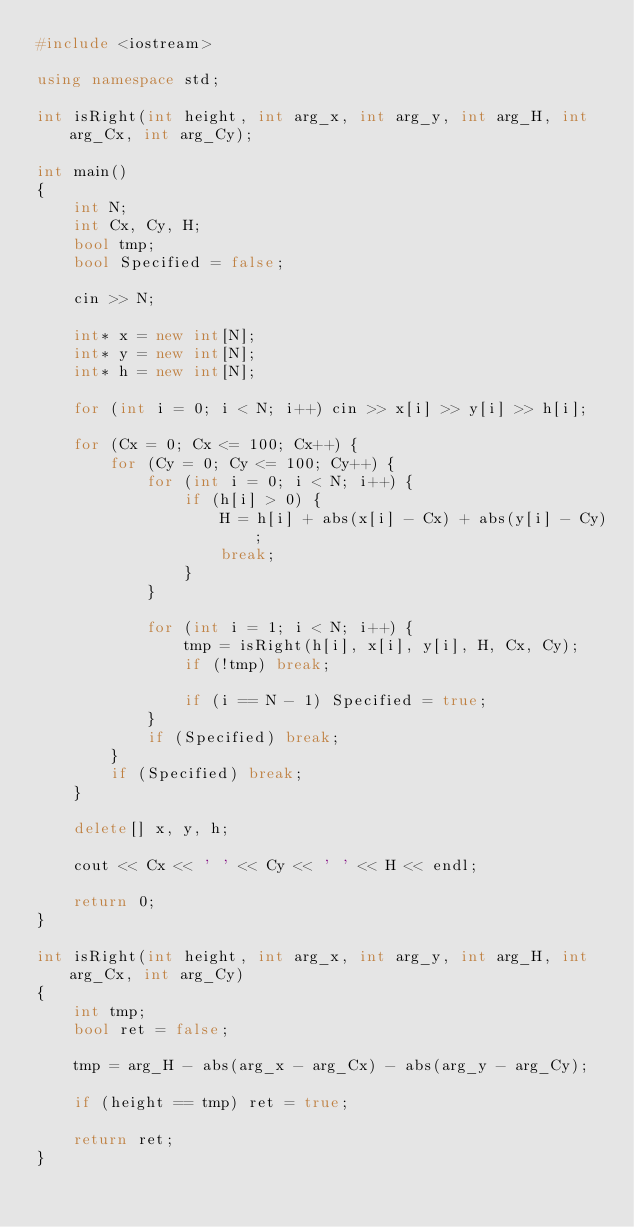<code> <loc_0><loc_0><loc_500><loc_500><_C++_>#include <iostream>

using namespace std;

int isRight(int height, int arg_x, int arg_y, int arg_H, int arg_Cx, int arg_Cy);

int main()
{
	int N;
	int Cx, Cy, H;
	bool tmp;
	bool Specified = false;

	cin >> N;

	int* x = new int[N];
	int* y = new int[N];
	int* h = new int[N];

	for (int i = 0; i < N; i++) cin >> x[i] >> y[i] >> h[i];

	for (Cx = 0; Cx <= 100; Cx++) {
		for (Cy = 0; Cy <= 100; Cy++) {
			for (int i = 0; i < N; i++) {
				if (h[i] > 0) {
					H = h[i] + abs(x[i] - Cx) + abs(y[i] - Cy);
					break;
				}
			}

			for (int i = 1; i < N; i++) {
				tmp = isRight(h[i], x[i], y[i], H, Cx, Cy);
				if (!tmp) break;

				if (i == N - 1) Specified = true;
			}
			if (Specified) break;
		}
		if (Specified) break;
	}
	
	delete[] x, y, h;

	cout << Cx << ' ' << Cy << ' ' << H << endl;

	return 0;
}

int isRight(int height, int arg_x, int arg_y, int arg_H, int arg_Cx, int arg_Cy)
{
	int tmp;
	bool ret = false;

	tmp = arg_H - abs(arg_x - arg_Cx) - abs(arg_y - arg_Cy);

	if (height == tmp) ret = true;

	return ret;
}
</code> 